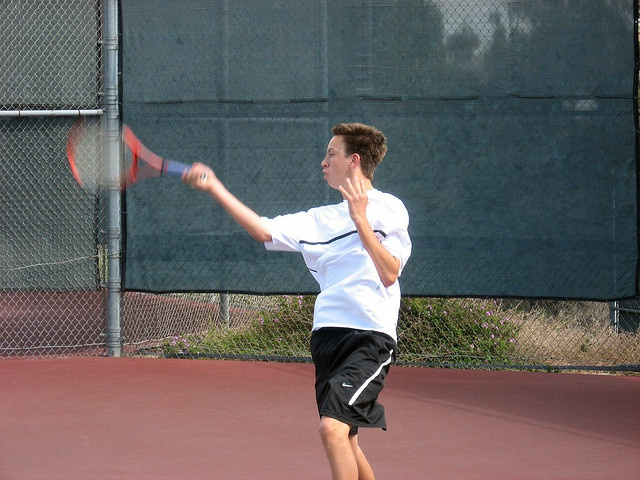Describe the objects in this image and their specific colors. I can see people in gray, white, black, and tan tones and tennis racket in gray, darkgray, and brown tones in this image. 